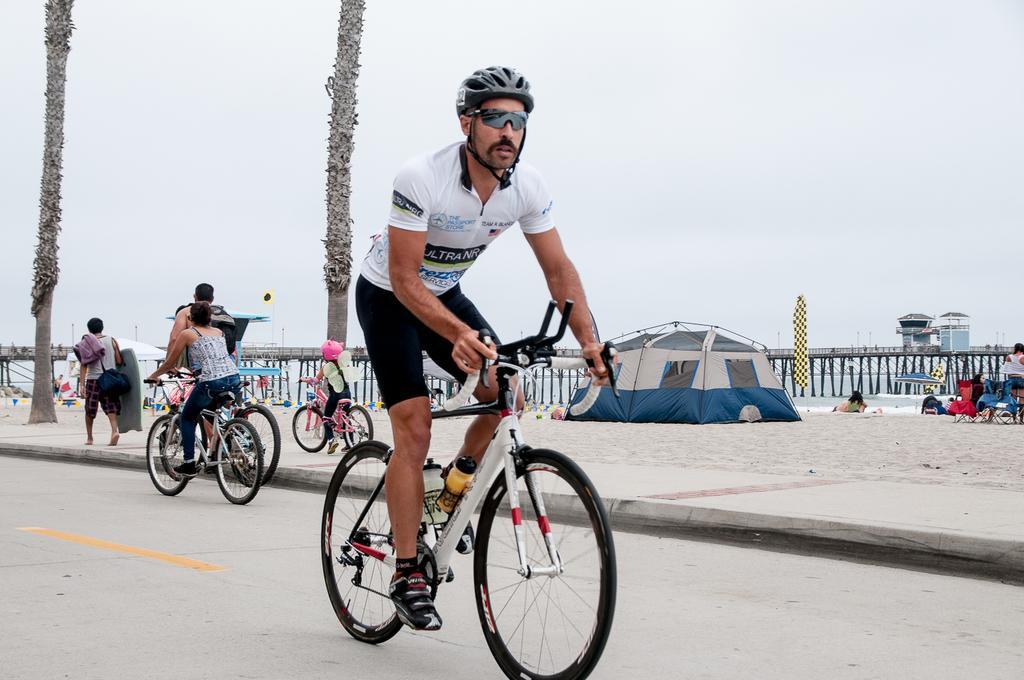Please provide a concise description of this image. There is a man who is riding a bicycle by holding its handle and wearing a helmet and the spectacles. At the back side there are three other people who are riding bicycle and one man is walking on side walk by holding a bag. At the background we can see two trees and white sky. On the right side there is a tent and sand and a umbrella. 